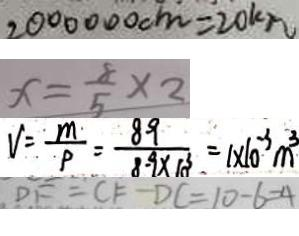<formula> <loc_0><loc_0><loc_500><loc_500>2 0 0 0 0 0 0 c m = 2 0 k m 
 x = \frac { 8 } { 5 } \times 2 
 V = \frac { m } { P } = \frac { 8 9 } { 8 . 9 \times 1 0 ^ { 3 } } = 1 \times 1 0 ^ { - 3 } m ^ { 3 } 
 D F = C F - D C = 1 0 - 6 = 4</formula> 